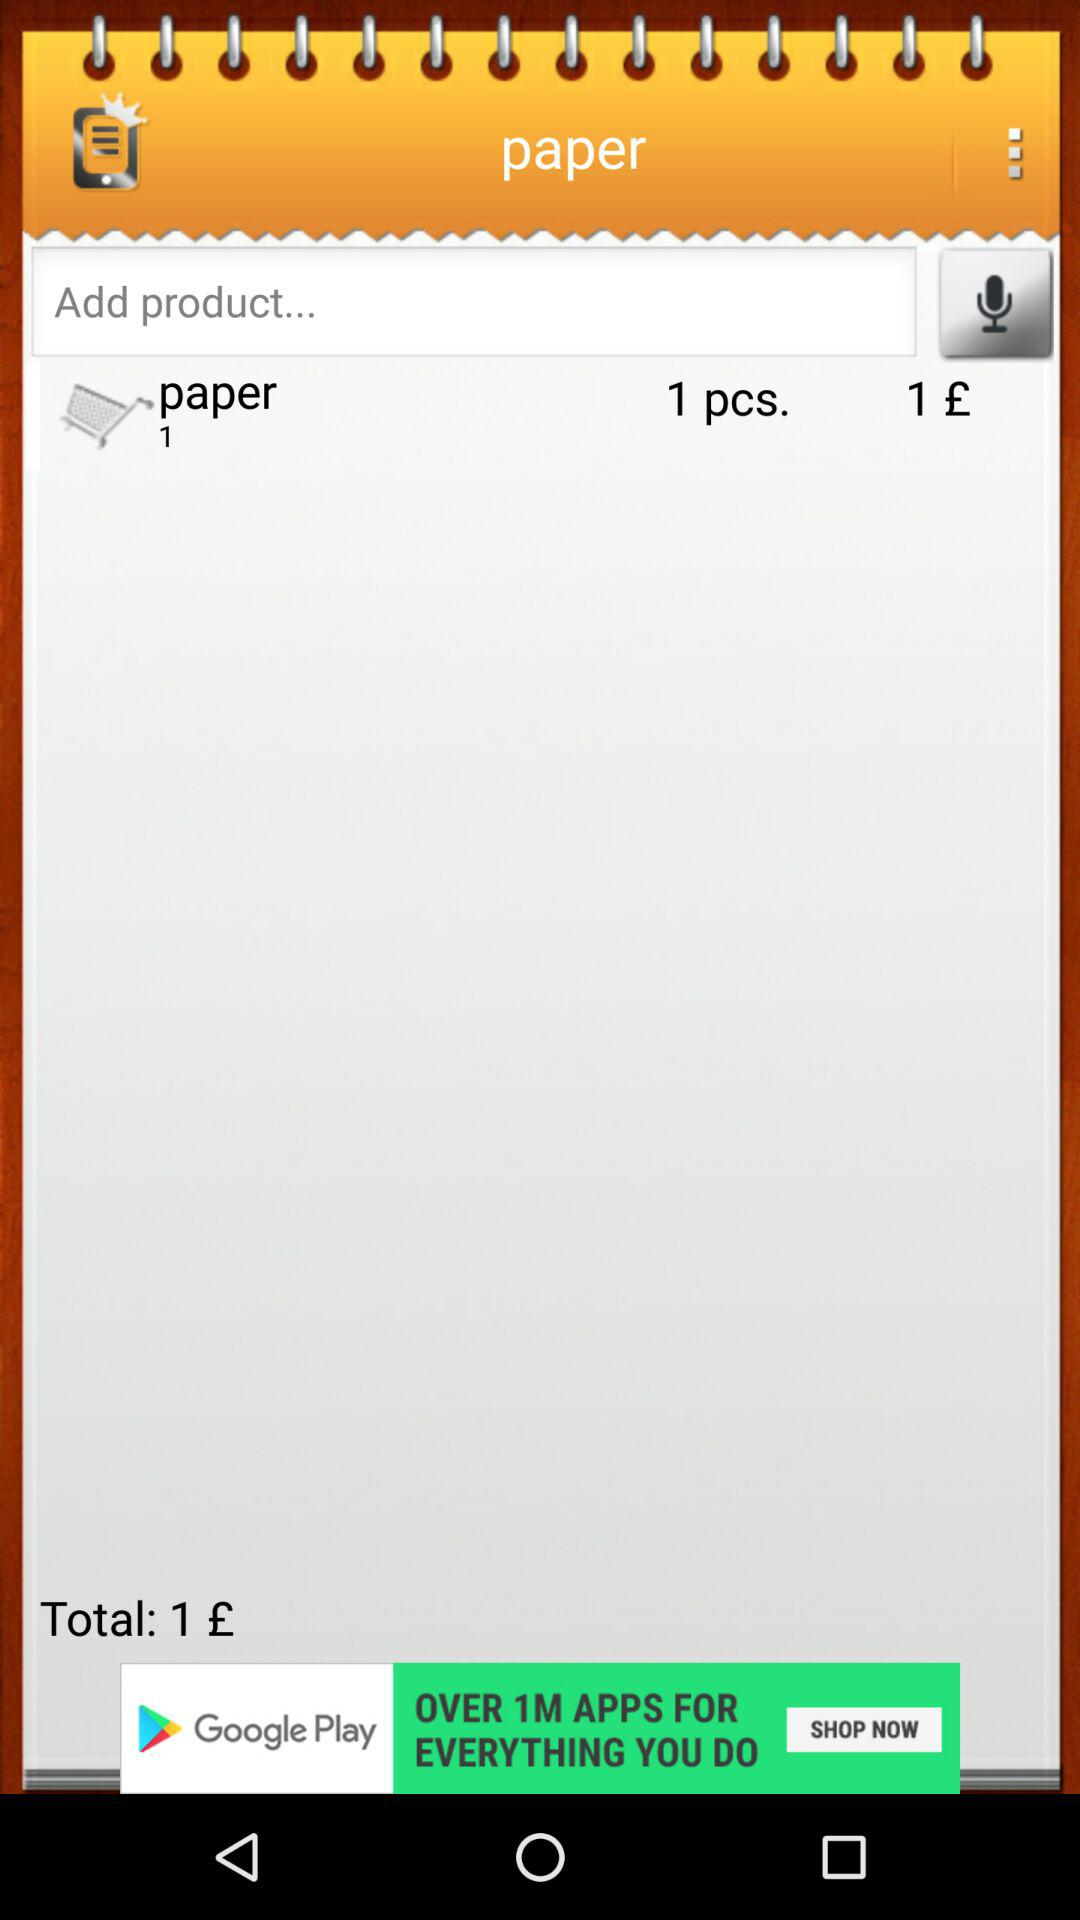How many items are in the shopping cart?
Answer the question using a single word or phrase. 1 